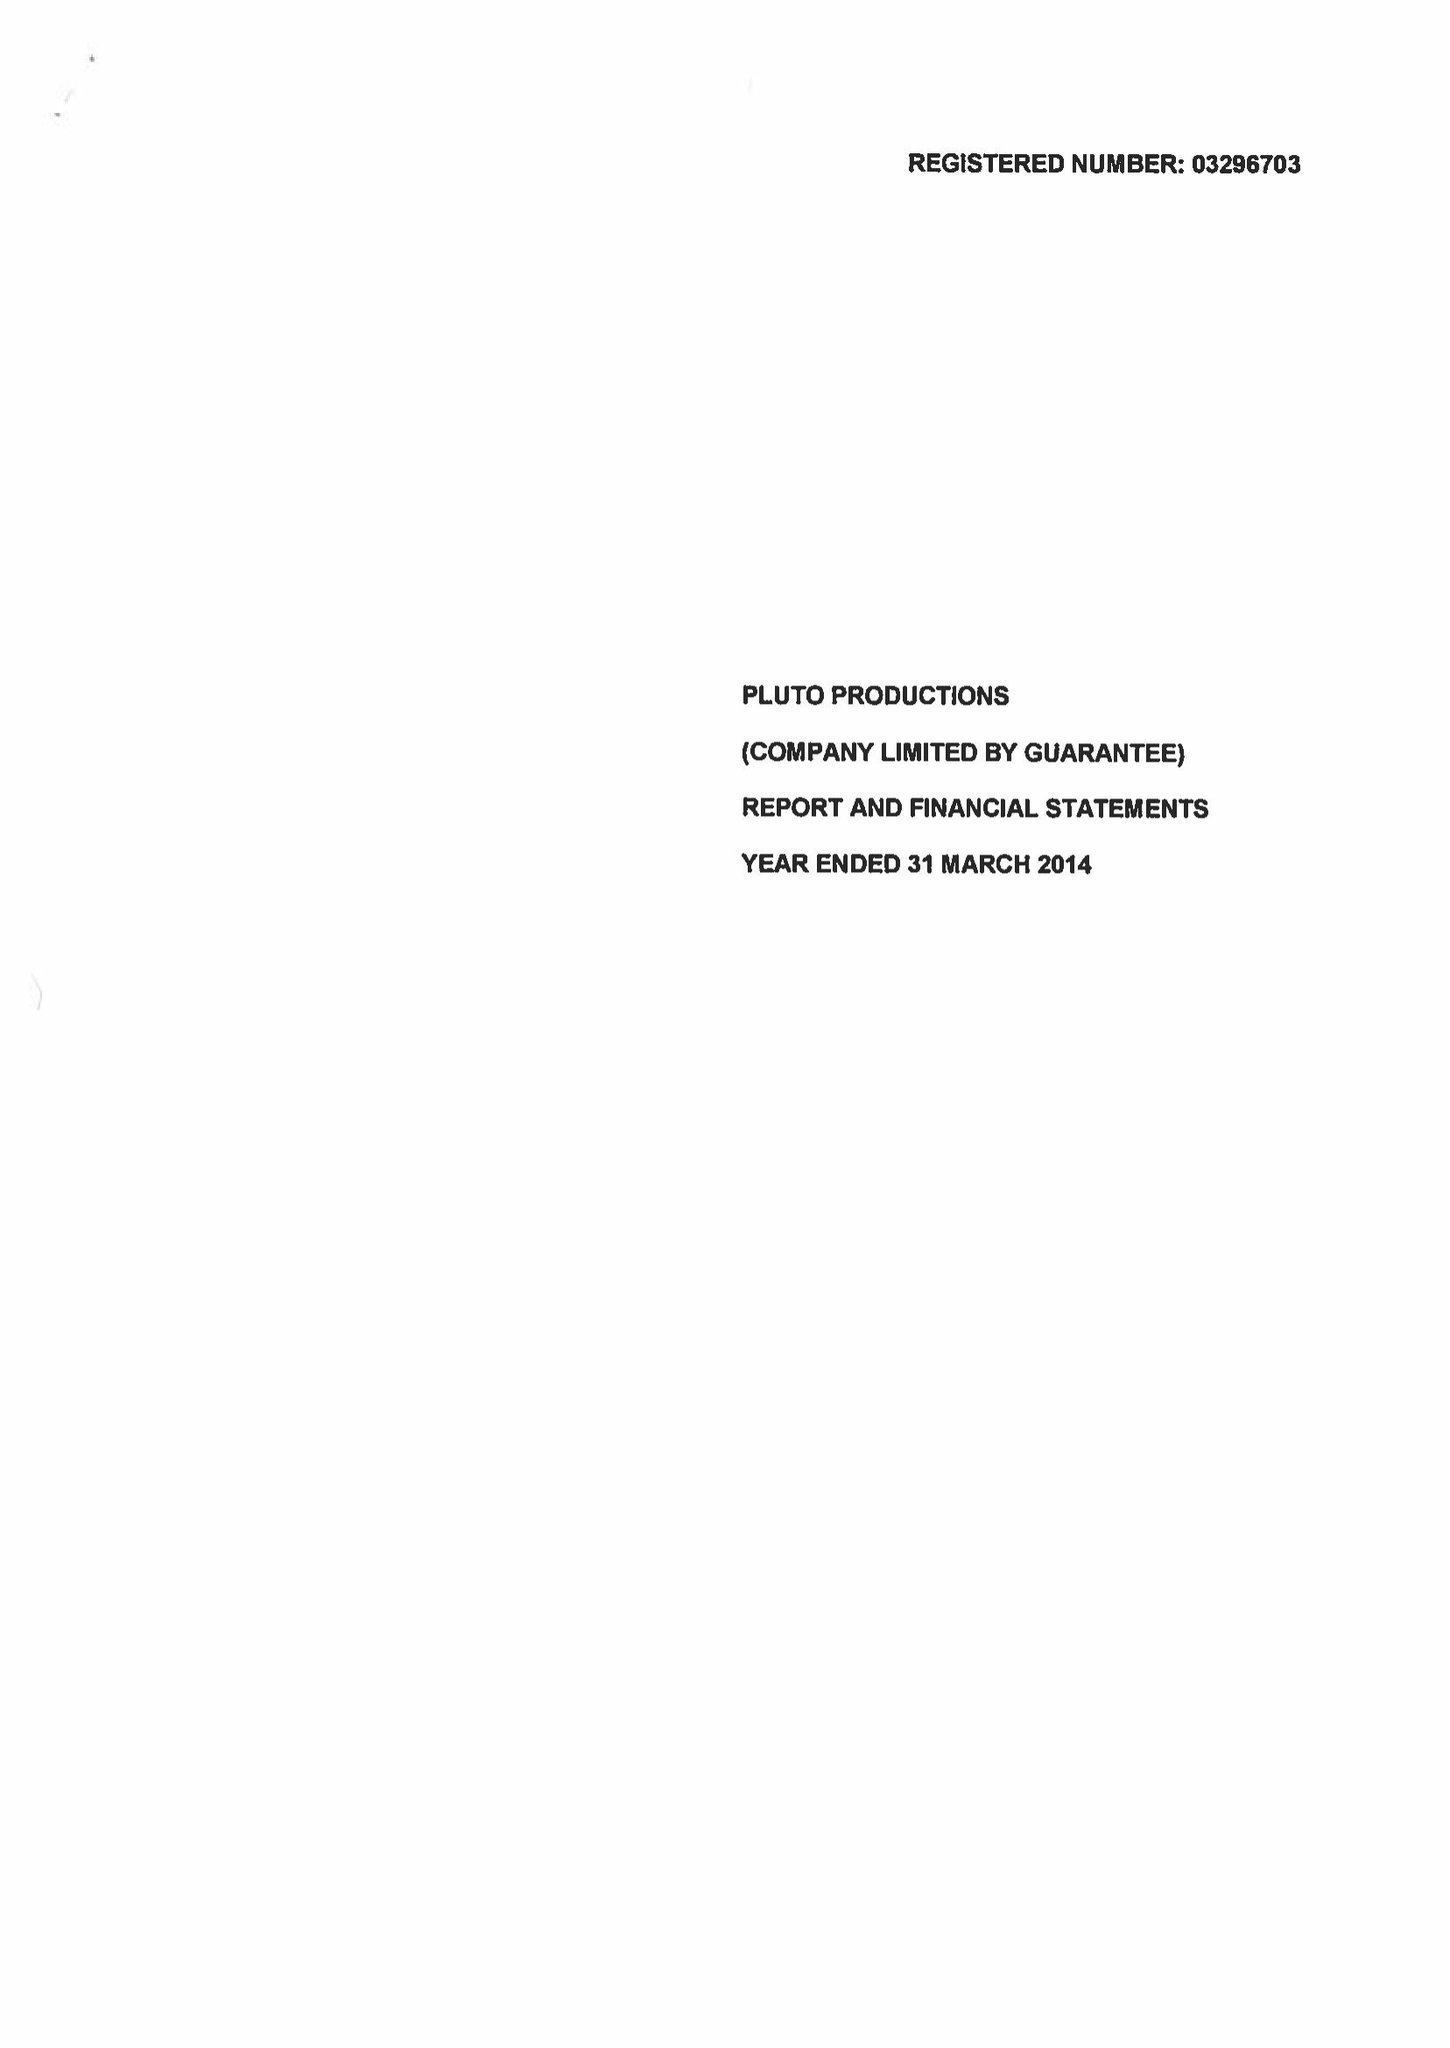What is the value for the report_date?
Answer the question using a single word or phrase. 2014-03-31 